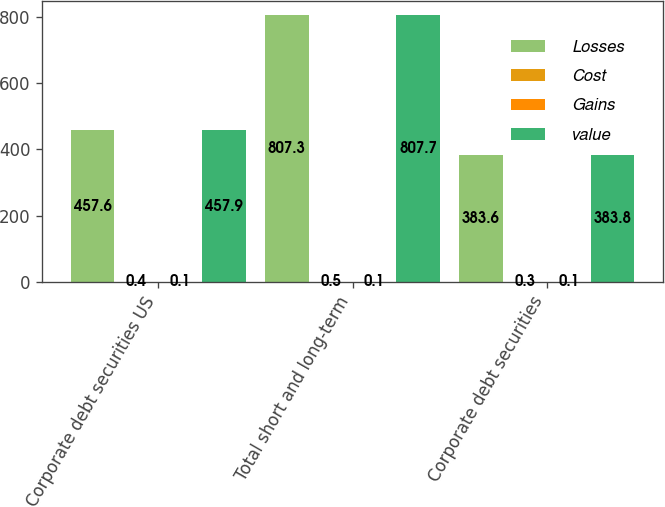Convert chart to OTSL. <chart><loc_0><loc_0><loc_500><loc_500><stacked_bar_chart><ecel><fcel>Corporate debt securities US<fcel>Total short and long-term<fcel>Corporate debt securities<nl><fcel>Losses<fcel>457.6<fcel>807.3<fcel>383.6<nl><fcel>Cost<fcel>0.4<fcel>0.5<fcel>0.3<nl><fcel>Gains<fcel>0.1<fcel>0.1<fcel>0.1<nl><fcel>value<fcel>457.9<fcel>807.7<fcel>383.8<nl></chart> 